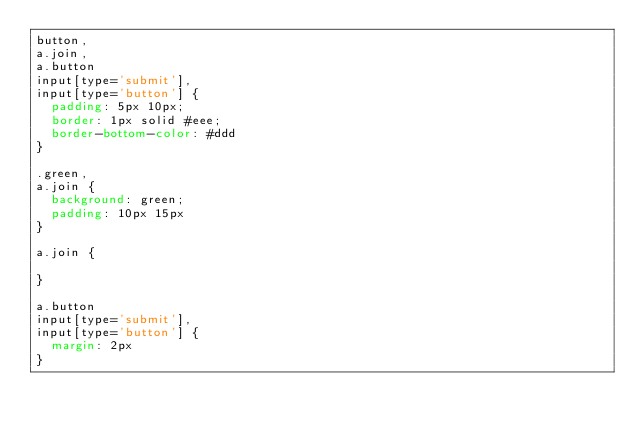Convert code to text. <code><loc_0><loc_0><loc_500><loc_500><_CSS_>button,
a.join,
a.button
input[type='submit'],
input[type='button'] {
  padding: 5px 10px;
  border: 1px solid #eee;
  border-bottom-color: #ddd
}

.green,
a.join {
  background: green;
  padding: 10px 15px
}

a.join {

}

a.button
input[type='submit'],
input[type='button'] {
  margin: 2px
}</code> 